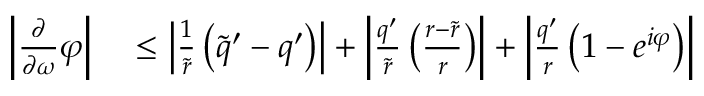Convert formula to latex. <formula><loc_0><loc_0><loc_500><loc_500>\begin{array} { r l } { \left | \frac { \partial } { \partial \omega } \varphi \right | } & \leq \left | \frac { 1 } { \widetilde { r } } \left ( \widetilde { q } ^ { \prime } - q ^ { \prime } \right ) \right | + \left | \frac { q ^ { \prime } } { \widetilde { r } } \left ( \frac { r - \widetilde { r } } { r } \right ) \right | + \left | \frac { q ^ { \prime } } { r } \left ( 1 - e ^ { i \varphi } \right ) \right | } \end{array}</formula> 